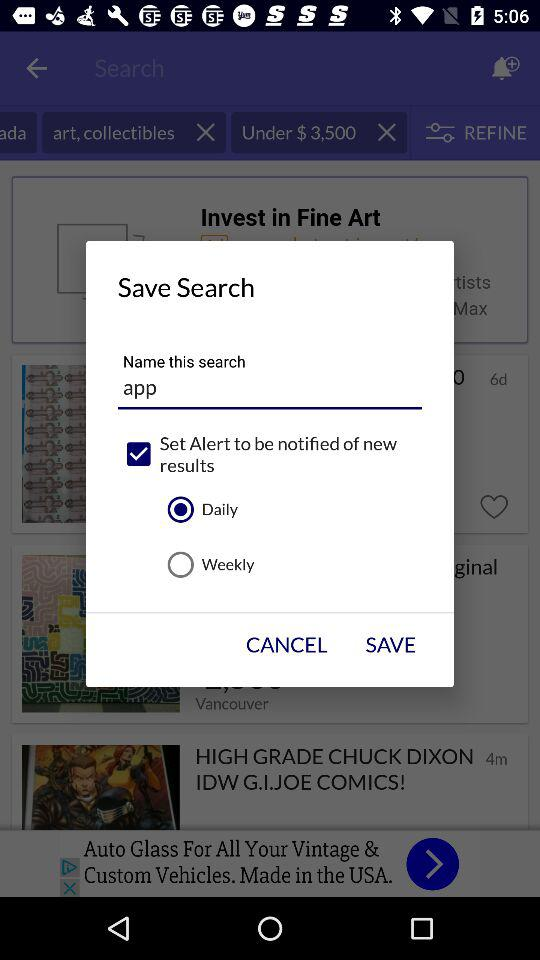How many more items are in the clothing category than in the baby items category?
Answer the question using a single word or phrase. 305066 